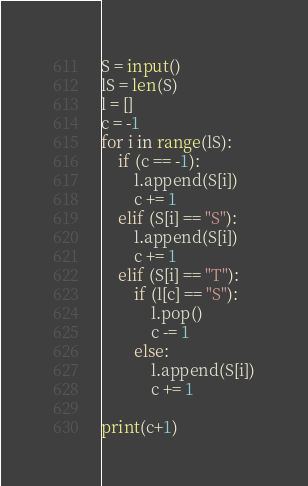Convert code to text. <code><loc_0><loc_0><loc_500><loc_500><_Python_>S = input()
lS = len(S)
l = []
c = -1
for i in range(lS):
    if (c == -1):
        l.append(S[i])
        c += 1
    elif (S[i] == "S"):
        l.append(S[i])
        c += 1
    elif (S[i] == "T"):
        if (l[c] == "S"):
            l.pop()
            c -= 1
        else:
            l.append(S[i])
            c += 1
            
print(c+1)
</code> 